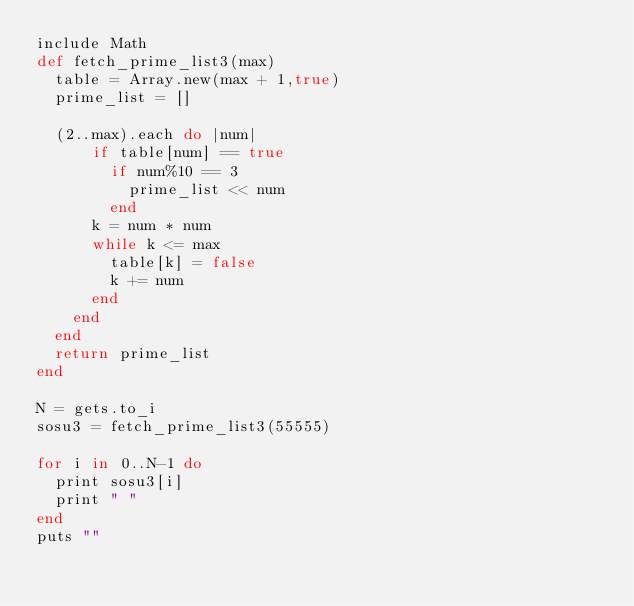Convert code to text. <code><loc_0><loc_0><loc_500><loc_500><_Ruby_>include Math
def fetch_prime_list3(max)
  table = Array.new(max + 1,true)
  prime_list = []

  (2..max).each do |num|
      if table[num] == true
        if num%10 == 3
          prime_list << num
        end
      k = num * num
      while k <= max
        table[k] = false
        k += num
      end
    end
  end
  return prime_list
end

N = gets.to_i
sosu3 = fetch_prime_list3(55555)

for i in 0..N-1 do
  print sosu3[i]
  print " "
end
puts ""


</code> 